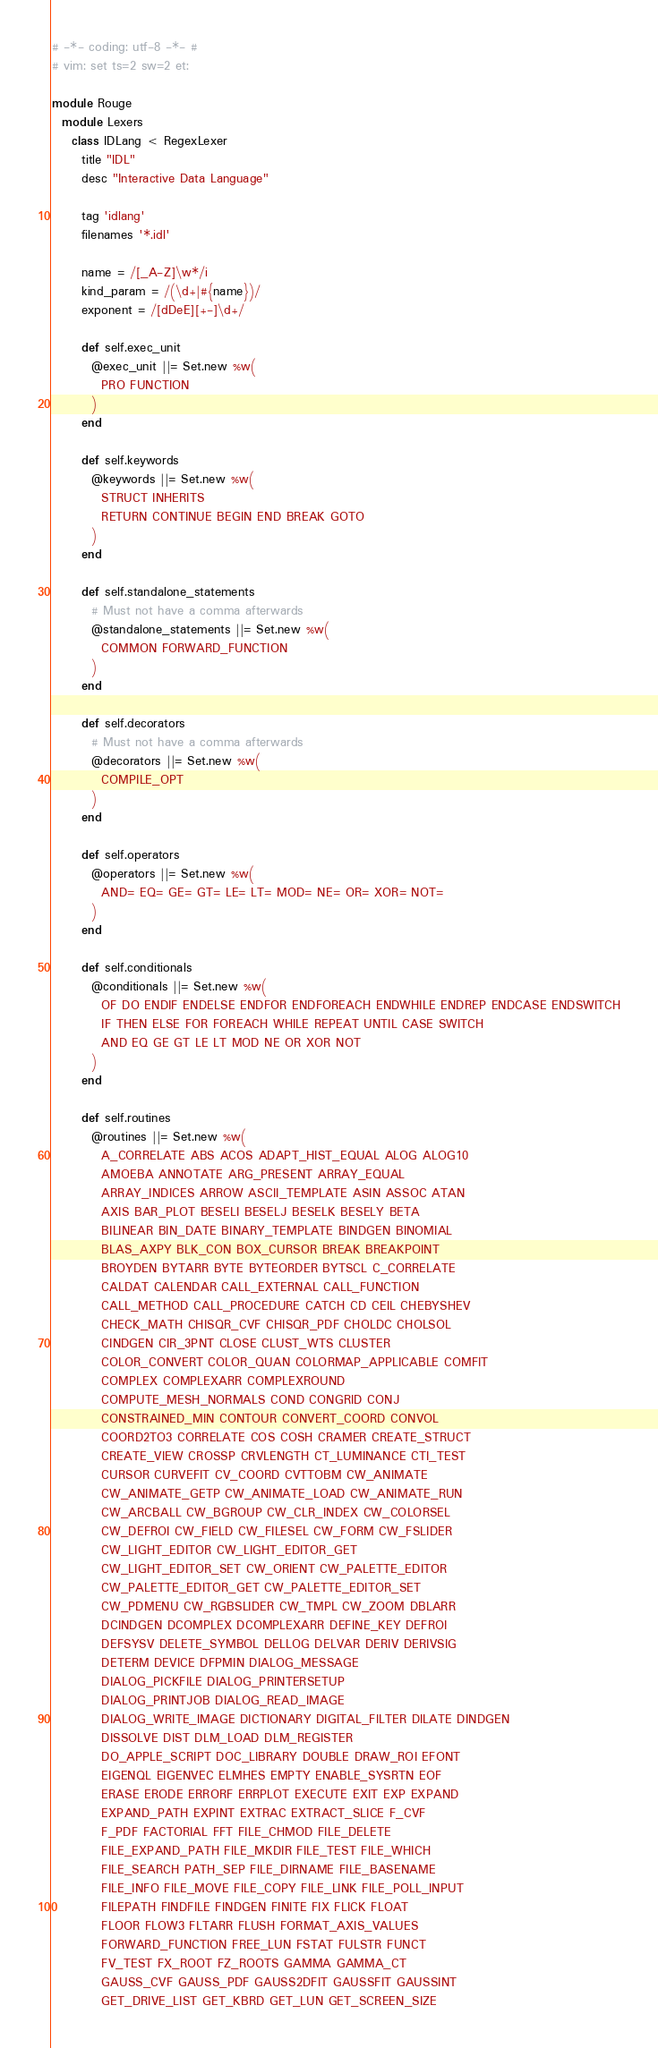<code> <loc_0><loc_0><loc_500><loc_500><_Ruby_># -*- coding: utf-8 -*- #
# vim: set ts=2 sw=2 et:

module Rouge
  module Lexers
    class IDLang < RegexLexer
      title "IDL"
      desc "Interactive Data Language"

      tag 'idlang'
      filenames '*.idl'

      name = /[_A-Z]\w*/i
      kind_param = /(\d+|#{name})/
      exponent = /[dDeE][+-]\d+/

      def self.exec_unit
        @exec_unit ||= Set.new %w(
          PRO FUNCTION
        )
      end

      def self.keywords
        @keywords ||= Set.new %w(
          STRUCT INHERITS
          RETURN CONTINUE BEGIN END BREAK GOTO
        )
      end

      def self.standalone_statements
        # Must not have a comma afterwards
        @standalone_statements ||= Set.new %w(
          COMMON FORWARD_FUNCTION
        )
      end

      def self.decorators
        # Must not have a comma afterwards
        @decorators ||= Set.new %w(
          COMPILE_OPT
        )
      end

      def self.operators
        @operators ||= Set.new %w(
          AND= EQ= GE= GT= LE= LT= MOD= NE= OR= XOR= NOT=
        )
      end

      def self.conditionals
        @conditionals ||= Set.new %w(
          OF DO ENDIF ENDELSE ENDFOR ENDFOREACH ENDWHILE ENDREP ENDCASE ENDSWITCH
          IF THEN ELSE FOR FOREACH WHILE REPEAT UNTIL CASE SWITCH
          AND EQ GE GT LE LT MOD NE OR XOR NOT
        )
      end

      def self.routines
        @routines ||= Set.new %w(
          A_CORRELATE ABS ACOS ADAPT_HIST_EQUAL ALOG ALOG10
          AMOEBA ANNOTATE ARG_PRESENT ARRAY_EQUAL
          ARRAY_INDICES ARROW ASCII_TEMPLATE ASIN ASSOC ATAN
          AXIS BAR_PLOT BESELI BESELJ BESELK BESELY BETA
          BILINEAR BIN_DATE BINARY_TEMPLATE BINDGEN BINOMIAL
          BLAS_AXPY BLK_CON BOX_CURSOR BREAK BREAKPOINT
          BROYDEN BYTARR BYTE BYTEORDER BYTSCL C_CORRELATE
          CALDAT CALENDAR CALL_EXTERNAL CALL_FUNCTION
          CALL_METHOD CALL_PROCEDURE CATCH CD CEIL CHEBYSHEV
          CHECK_MATH CHISQR_CVF CHISQR_PDF CHOLDC CHOLSOL
          CINDGEN CIR_3PNT CLOSE CLUST_WTS CLUSTER
          COLOR_CONVERT COLOR_QUAN COLORMAP_APPLICABLE COMFIT
          COMPLEX COMPLEXARR COMPLEXROUND
          COMPUTE_MESH_NORMALS COND CONGRID CONJ
          CONSTRAINED_MIN CONTOUR CONVERT_COORD CONVOL
          COORD2TO3 CORRELATE COS COSH CRAMER CREATE_STRUCT
          CREATE_VIEW CROSSP CRVLENGTH CT_LUMINANCE CTI_TEST
          CURSOR CURVEFIT CV_COORD CVTTOBM CW_ANIMATE
          CW_ANIMATE_GETP CW_ANIMATE_LOAD CW_ANIMATE_RUN
          CW_ARCBALL CW_BGROUP CW_CLR_INDEX CW_COLORSEL
          CW_DEFROI CW_FIELD CW_FILESEL CW_FORM CW_FSLIDER
          CW_LIGHT_EDITOR CW_LIGHT_EDITOR_GET
          CW_LIGHT_EDITOR_SET CW_ORIENT CW_PALETTE_EDITOR
          CW_PALETTE_EDITOR_GET CW_PALETTE_EDITOR_SET
          CW_PDMENU CW_RGBSLIDER CW_TMPL CW_ZOOM DBLARR
          DCINDGEN DCOMPLEX DCOMPLEXARR DEFINE_KEY DEFROI
          DEFSYSV DELETE_SYMBOL DELLOG DELVAR DERIV DERIVSIG
          DETERM DEVICE DFPMIN DIALOG_MESSAGE
          DIALOG_PICKFILE DIALOG_PRINTERSETUP
          DIALOG_PRINTJOB DIALOG_READ_IMAGE
          DIALOG_WRITE_IMAGE DICTIONARY DIGITAL_FILTER DILATE DINDGEN
          DISSOLVE DIST DLM_LOAD DLM_REGISTER
          DO_APPLE_SCRIPT DOC_LIBRARY DOUBLE DRAW_ROI EFONT
          EIGENQL EIGENVEC ELMHES EMPTY ENABLE_SYSRTN EOF
          ERASE ERODE ERRORF ERRPLOT EXECUTE EXIT EXP EXPAND
          EXPAND_PATH EXPINT EXTRAC EXTRACT_SLICE F_CVF
          F_PDF FACTORIAL FFT FILE_CHMOD FILE_DELETE
          FILE_EXPAND_PATH FILE_MKDIR FILE_TEST FILE_WHICH
          FILE_SEARCH PATH_SEP FILE_DIRNAME FILE_BASENAME
          FILE_INFO FILE_MOVE FILE_COPY FILE_LINK FILE_POLL_INPUT
          FILEPATH FINDFILE FINDGEN FINITE FIX FLICK FLOAT
          FLOOR FLOW3 FLTARR FLUSH FORMAT_AXIS_VALUES
          FORWARD_FUNCTION FREE_LUN FSTAT FULSTR FUNCT
          FV_TEST FX_ROOT FZ_ROOTS GAMMA GAMMA_CT
          GAUSS_CVF GAUSS_PDF GAUSS2DFIT GAUSSFIT GAUSSINT
          GET_DRIVE_LIST GET_KBRD GET_LUN GET_SCREEN_SIZE</code> 